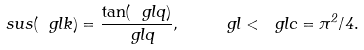Convert formula to latex. <formula><loc_0><loc_0><loc_500><loc_500>\ s u s ( \ g l k ) = \frac { \tan ( \ g l q ) } { \ g l q } , \quad \ g l < \ g l c = \pi ^ { 2 } / 4 .</formula> 